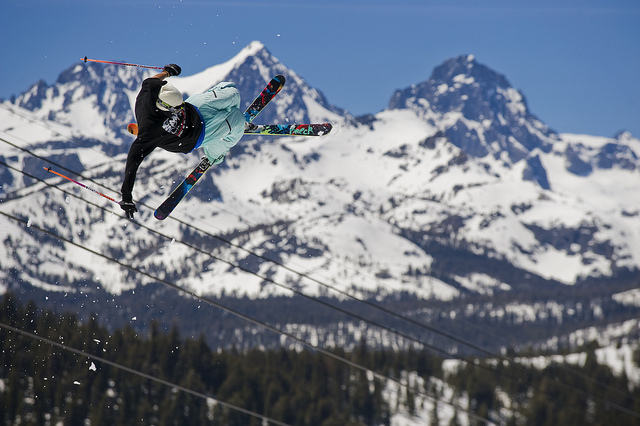<image>What activity is the man in the red shirt engaging in? There is no man in the red shirt in the image. However, other opinions suggest that the man might be skiing. What activity is the man in the red shirt engaging in? There is no man in red shirt engaging in any activity. 